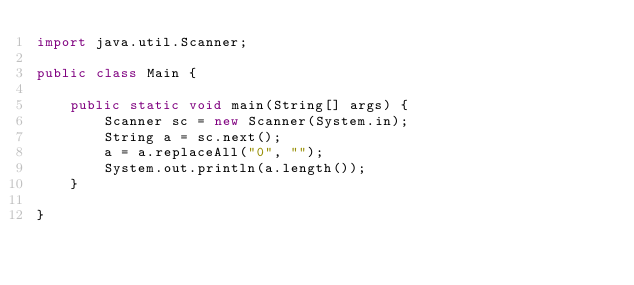Convert code to text. <code><loc_0><loc_0><loc_500><loc_500><_Java_>import java.util.Scanner;

public class Main {

    public static void main(String[] args) {
        Scanner sc = new Scanner(System.in);
        String a = sc.next();
        a = a.replaceAll("0", "");
        System.out.println(a.length());
    }

}</code> 